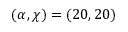Convert formula to latex. <formula><loc_0><loc_0><loc_500><loc_500>( \alpha , \chi ) = ( 2 0 , 2 0 )</formula> 